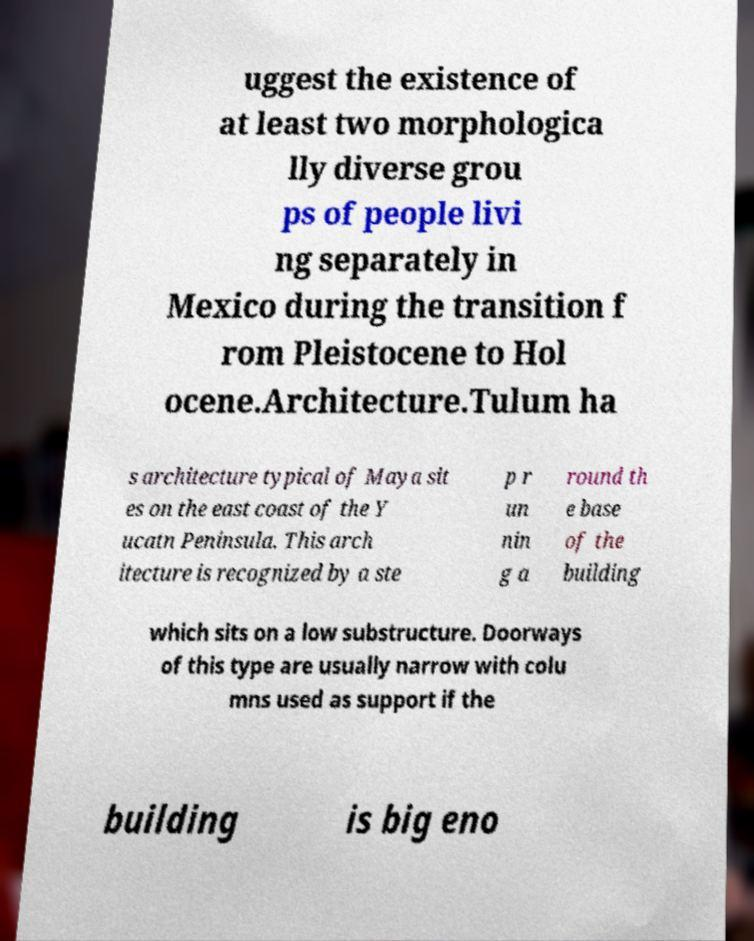Could you extract and type out the text from this image? uggest the existence of at least two morphologica lly diverse grou ps of people livi ng separately in Mexico during the transition f rom Pleistocene to Hol ocene.Architecture.Tulum ha s architecture typical of Maya sit es on the east coast of the Y ucatn Peninsula. This arch itecture is recognized by a ste p r un nin g a round th e base of the building which sits on a low substructure. Doorways of this type are usually narrow with colu mns used as support if the building is big eno 